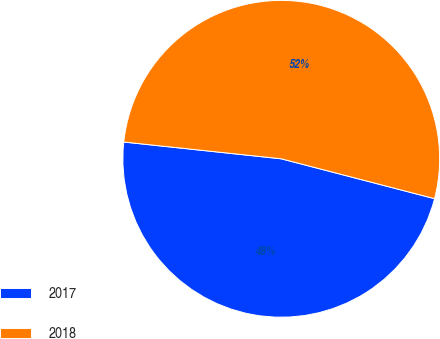<chart> <loc_0><loc_0><loc_500><loc_500><pie_chart><fcel>2017<fcel>2018<nl><fcel>47.64%<fcel>52.36%<nl></chart> 